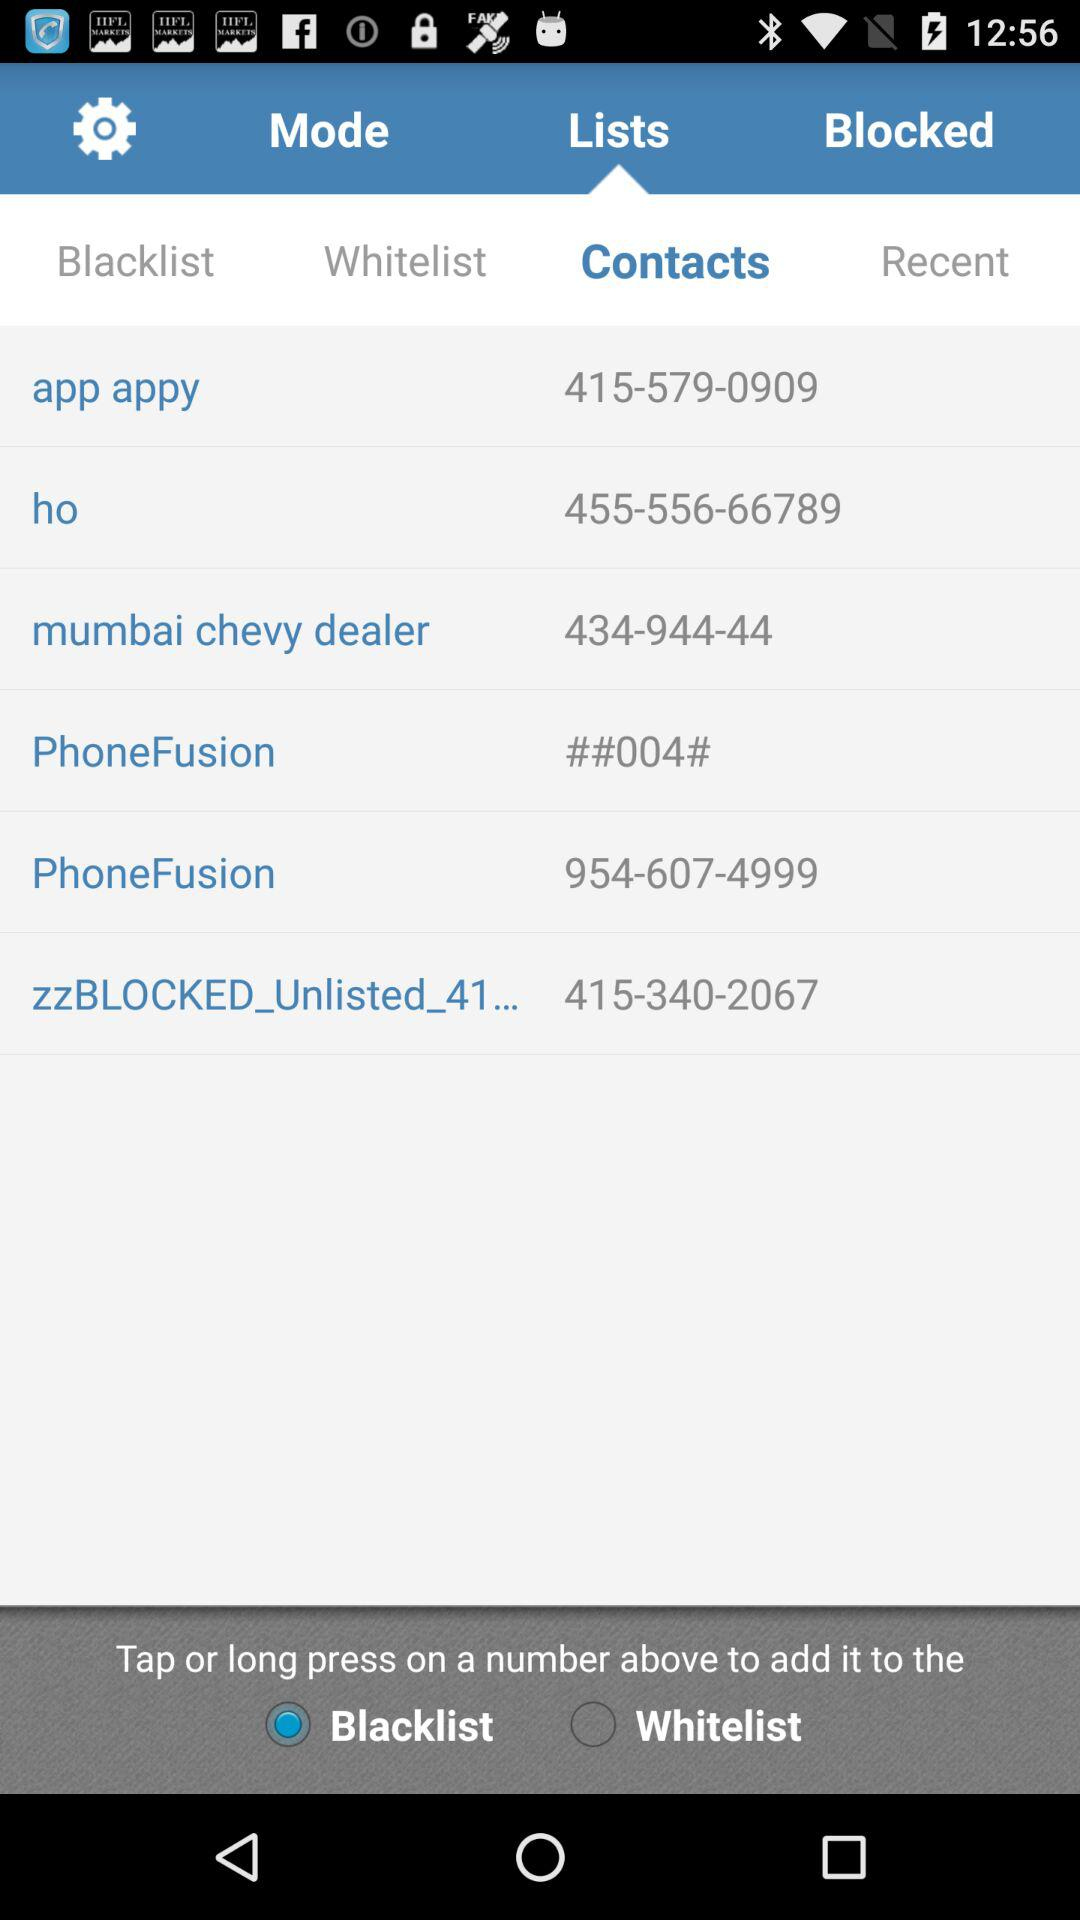Who has been blocked?
When the provided information is insufficient, respond with <no answer>. <no answer> 